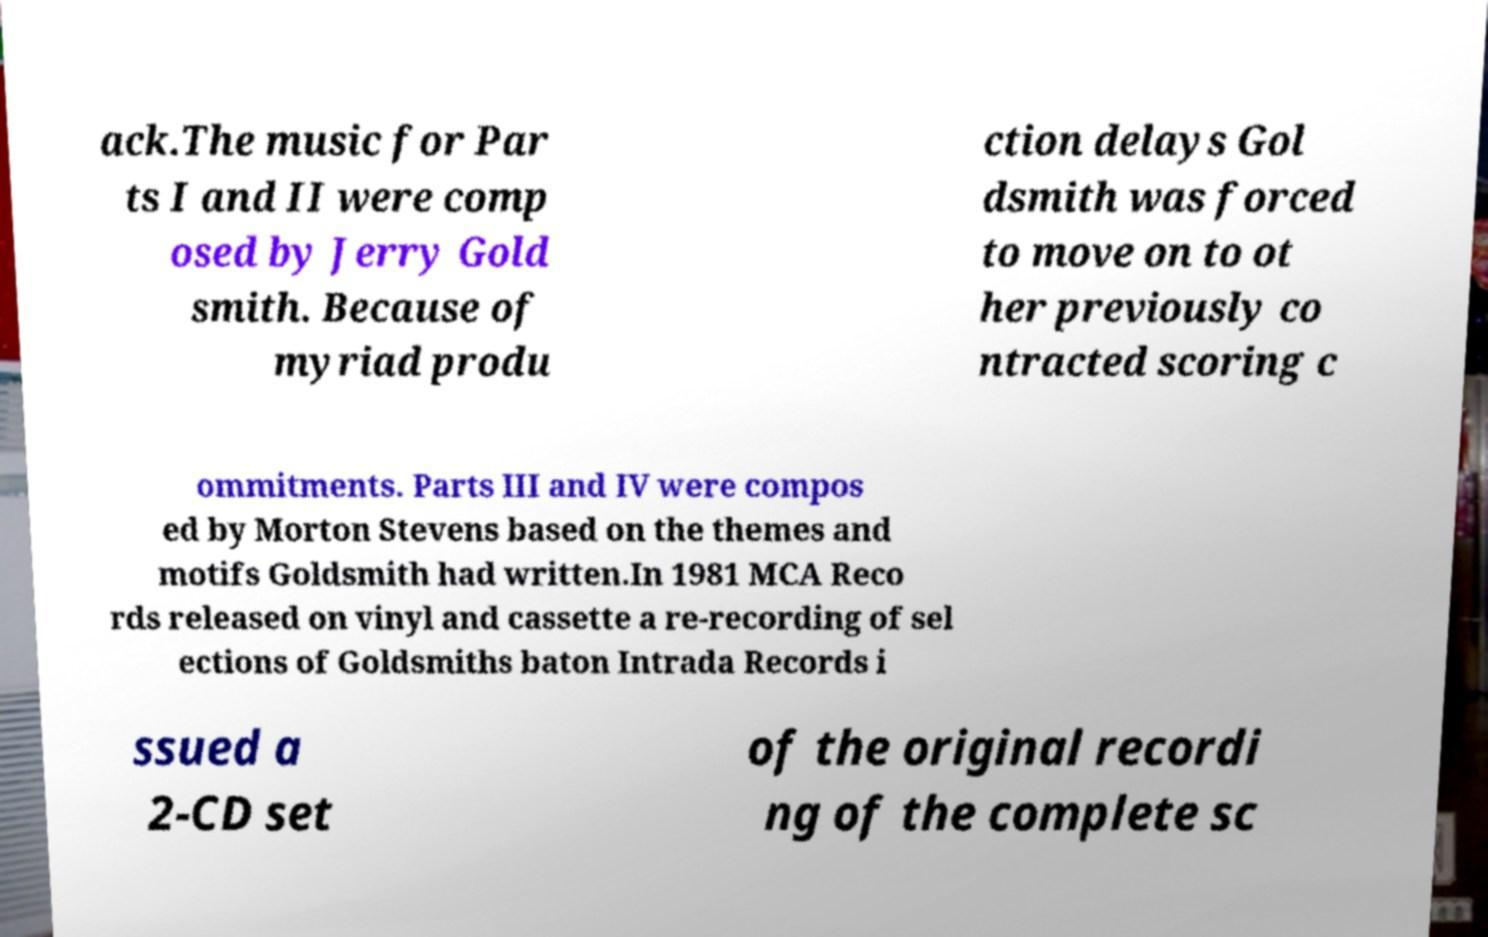For documentation purposes, I need the text within this image transcribed. Could you provide that? ack.The music for Par ts I and II were comp osed by Jerry Gold smith. Because of myriad produ ction delays Gol dsmith was forced to move on to ot her previously co ntracted scoring c ommitments. Parts III and IV were compos ed by Morton Stevens based on the themes and motifs Goldsmith had written.In 1981 MCA Reco rds released on vinyl and cassette a re-recording of sel ections of Goldsmiths baton Intrada Records i ssued a 2-CD set of the original recordi ng of the complete sc 